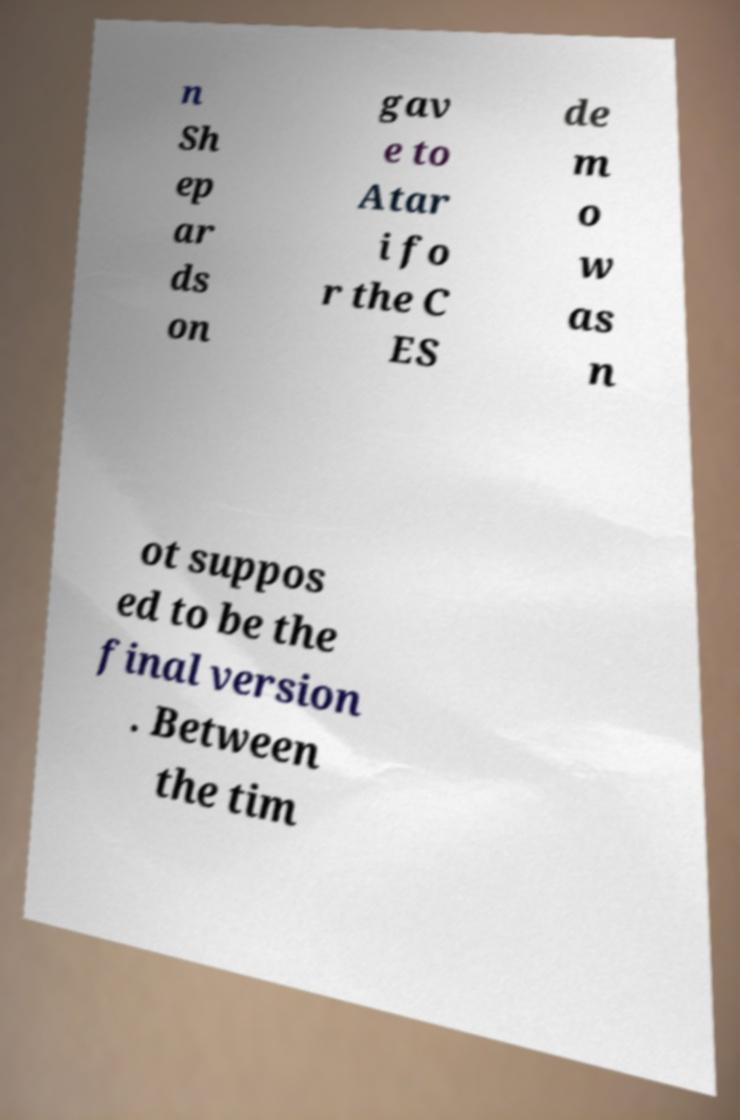Please read and relay the text visible in this image. What does it say? n Sh ep ar ds on gav e to Atar i fo r the C ES de m o w as n ot suppos ed to be the final version . Between the tim 